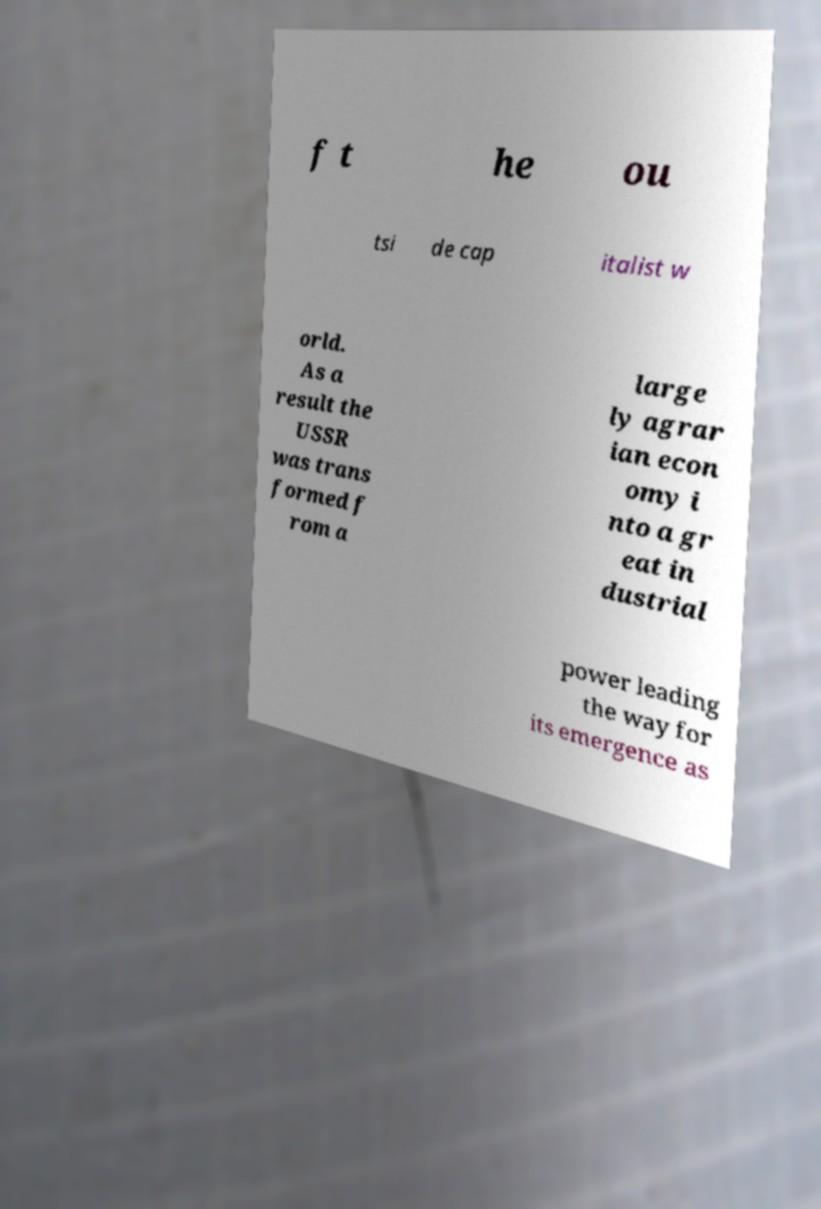Can you accurately transcribe the text from the provided image for me? f t he ou tsi de cap italist w orld. As a result the USSR was trans formed f rom a large ly agrar ian econ omy i nto a gr eat in dustrial power leading the way for its emergence as 